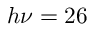<formula> <loc_0><loc_0><loc_500><loc_500>h \nu = 2 6</formula> 